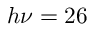<formula> <loc_0><loc_0><loc_500><loc_500>h \nu = 2 6</formula> 